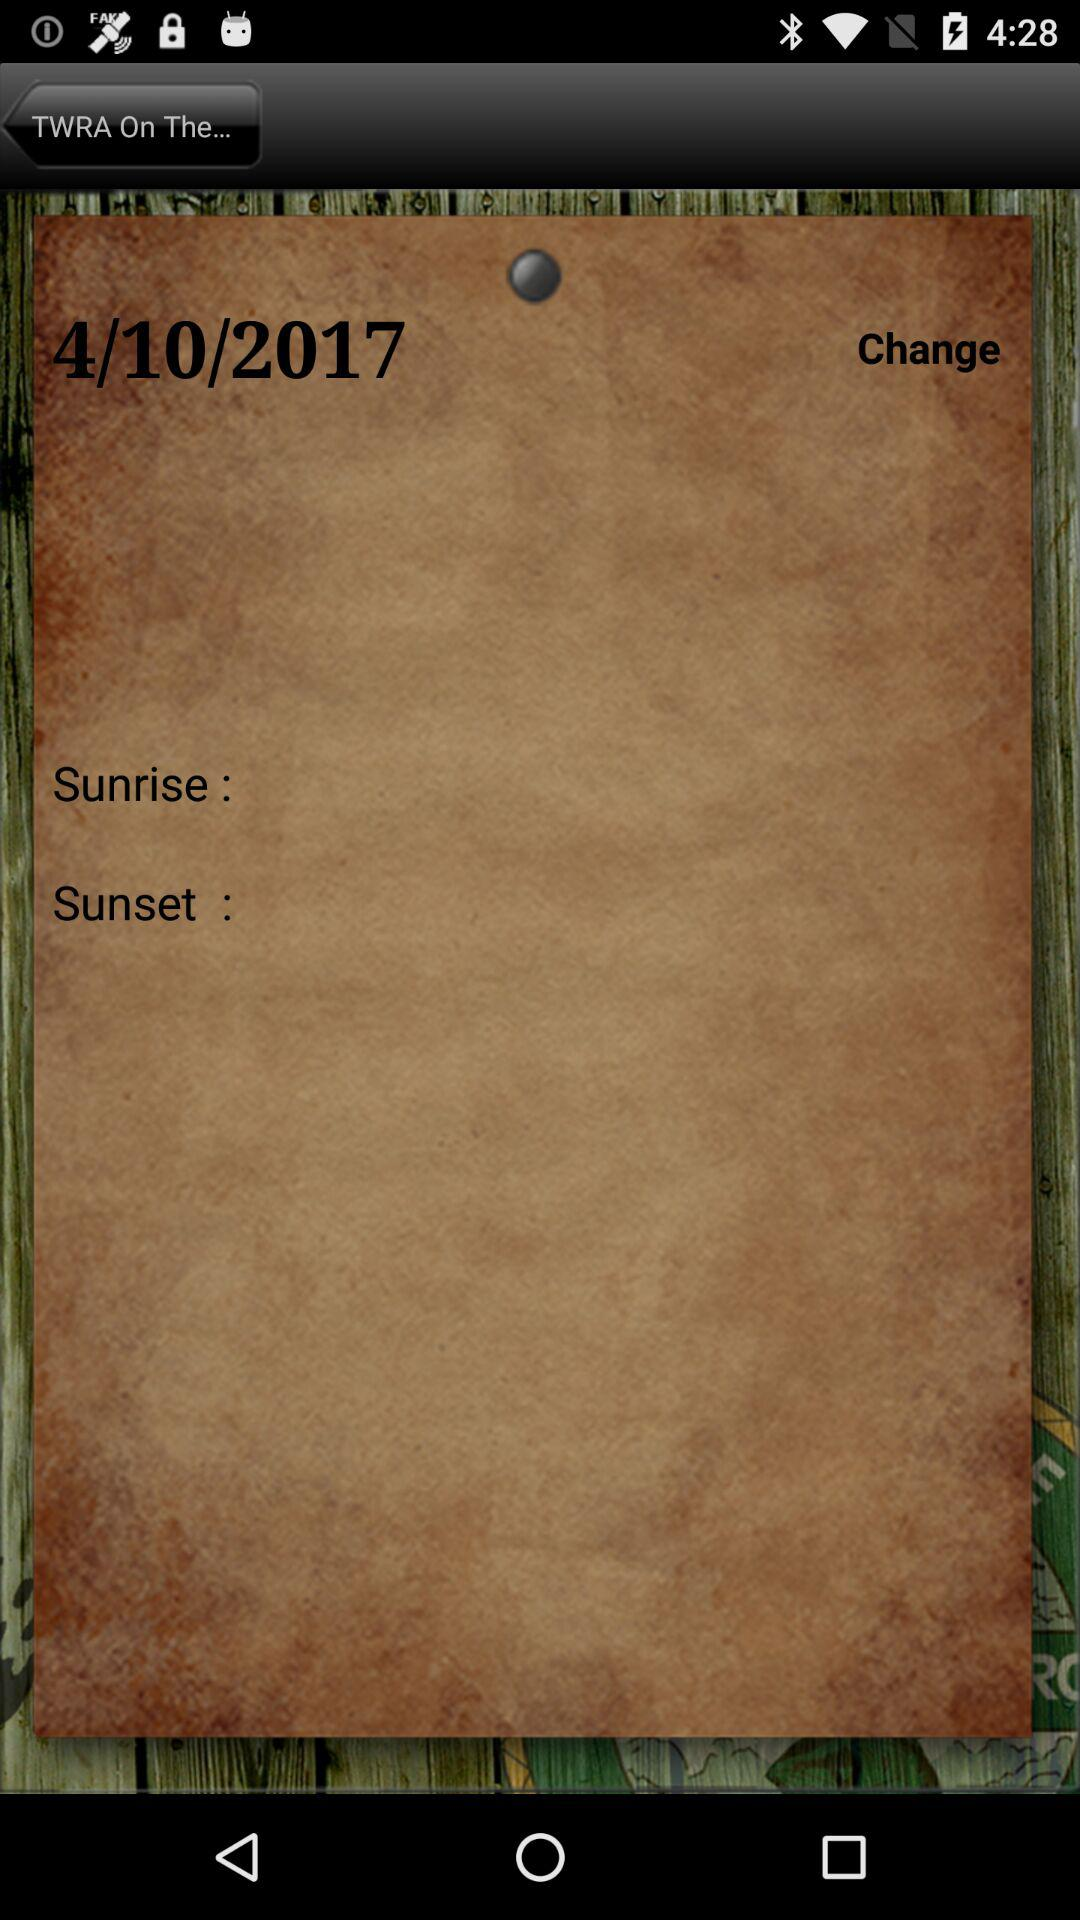What is the given date? The given date is April 10, 2017. 